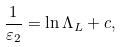Convert formula to latex. <formula><loc_0><loc_0><loc_500><loc_500>\frac { 1 } { \varepsilon _ { 2 } } = \ln \Lambda _ { L } + c ,</formula> 